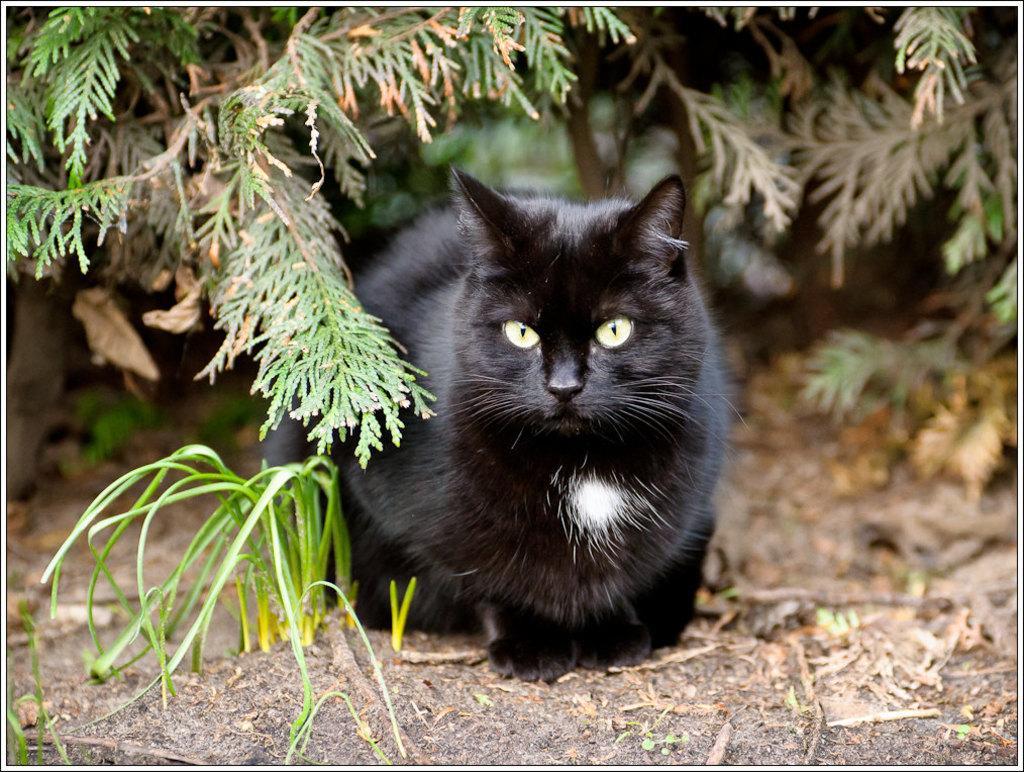Can you describe this image briefly? In the center of the image we can see a cat. At the bottom there is grass. In the background there are plants. 